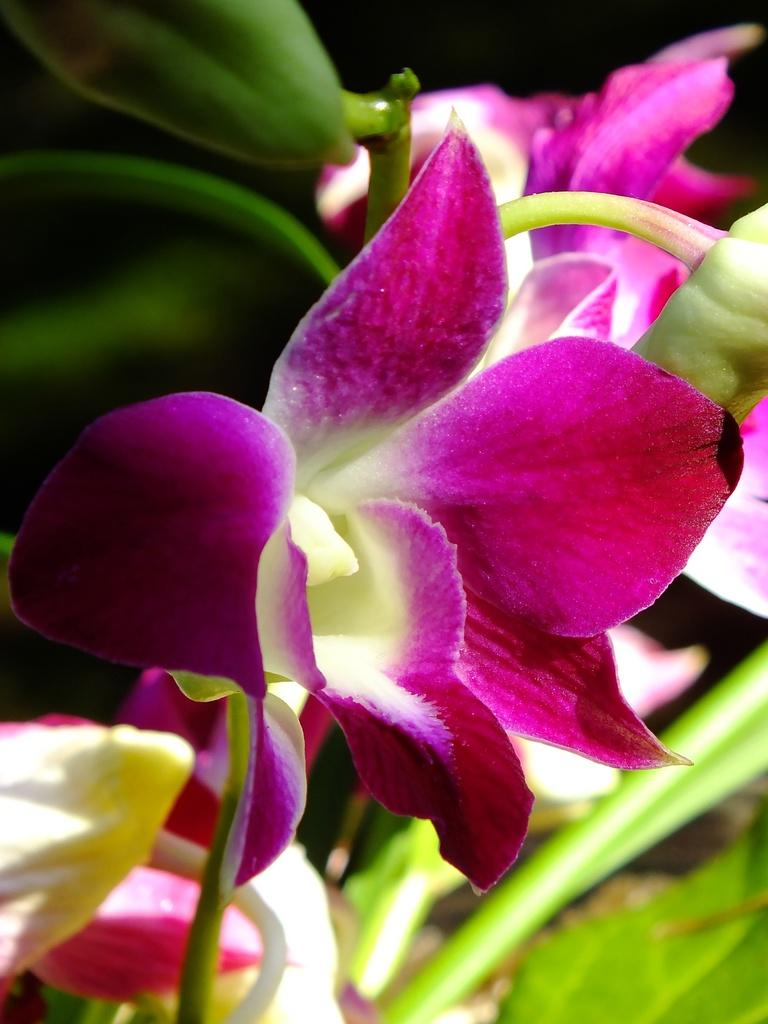What type of flora is present in the image? There are flowers in the image. What colors are the flowers? The flowers are in pink and white colors. What can be seen in the background of the image? There are leaves in the background of the image. What color are the leaves? The leaves are green in color. What type of comb is used to style the flowers in the image? There is no comb present in the image, as flowers do not require styling tools. 